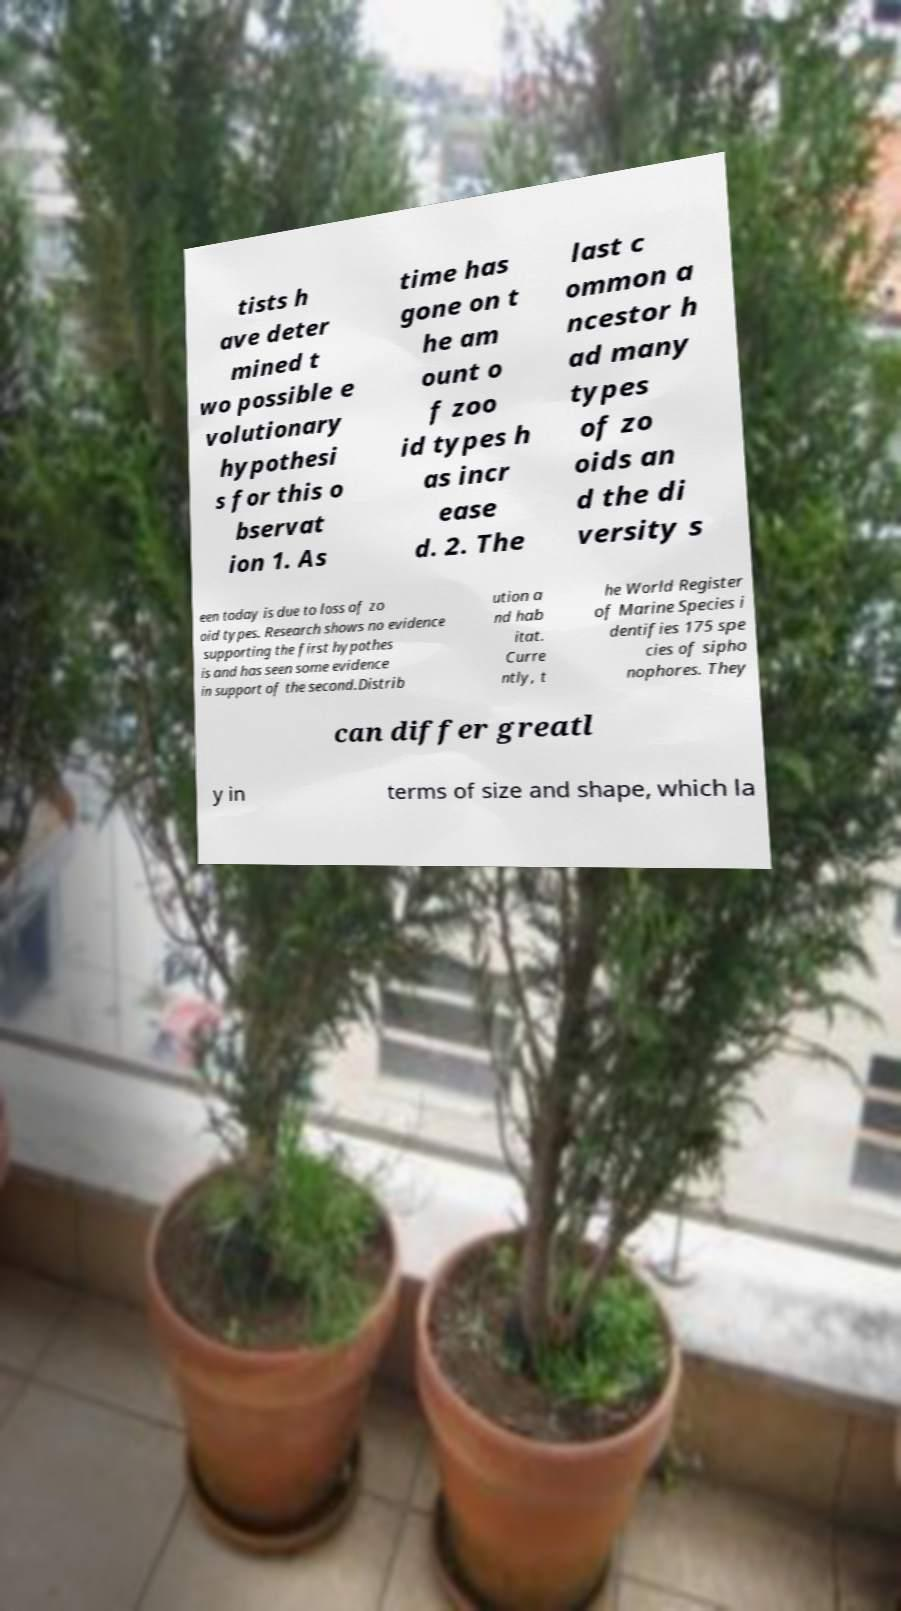Could you extract and type out the text from this image? tists h ave deter mined t wo possible e volutionary hypothesi s for this o bservat ion 1. As time has gone on t he am ount o f zoo id types h as incr ease d. 2. The last c ommon a ncestor h ad many types of zo oids an d the di versity s een today is due to loss of zo oid types. Research shows no evidence supporting the first hypothes is and has seen some evidence in support of the second.Distrib ution a nd hab itat. Curre ntly, t he World Register of Marine Species i dentifies 175 spe cies of sipho nophores. They can differ greatl y in terms of size and shape, which la 